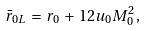Convert formula to latex. <formula><loc_0><loc_0><loc_500><loc_500>\bar { r } _ { 0 L } \, = \, r _ { 0 } \, + \, 1 2 u _ { 0 } M ^ { 2 } _ { 0 } \, ,</formula> 